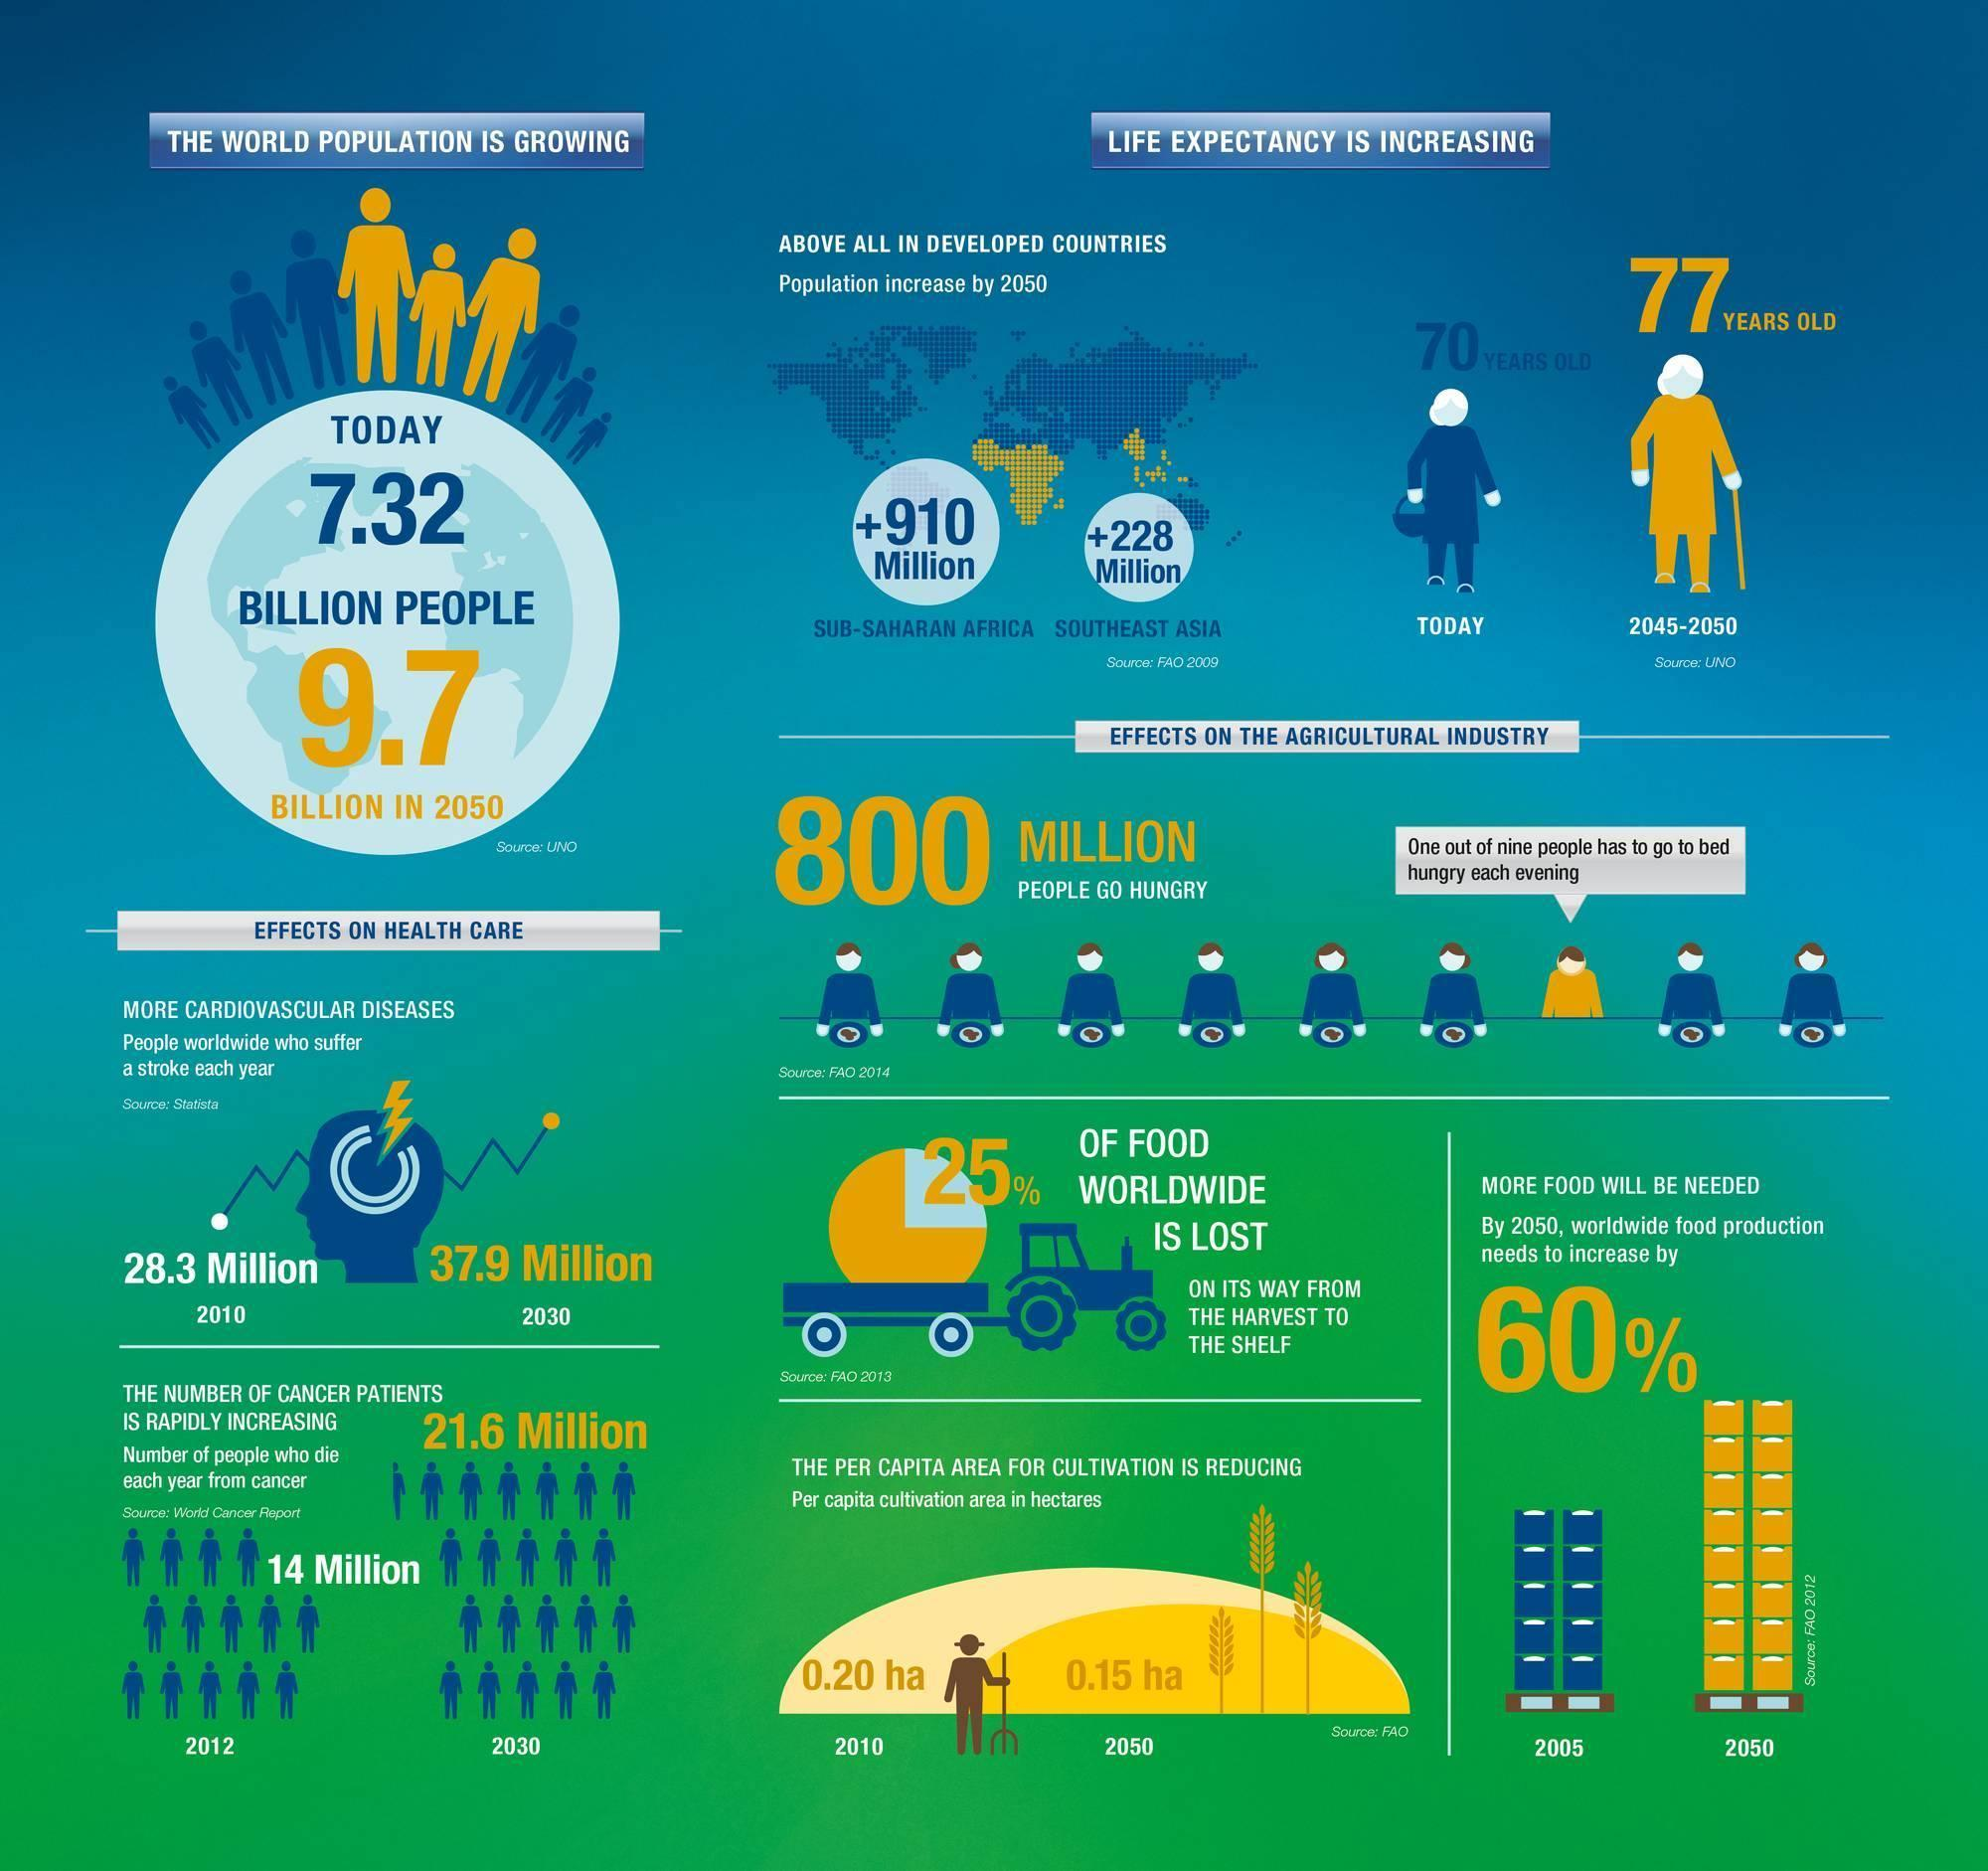What is the difference between life expectancy in 2045-2050 and today?
Answer the question with a short phrase. 7 What percentage of food worldwide is not lost on its way from the harvest to the shelf? 75% What is the difference between the number of cancer patients in 2030 and 2012? 7.6 Million Out of 9, how many go to bed without hungry? 8 